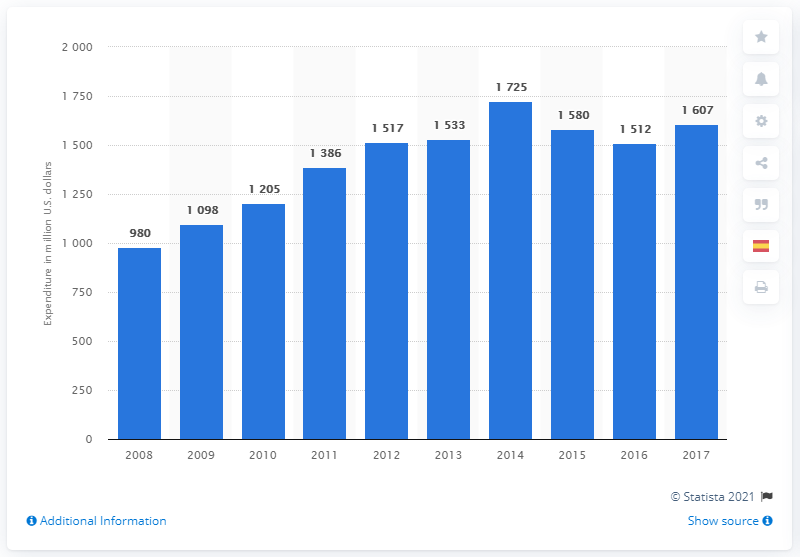Point out several critical features in this image. In 2017, Monsanto invested a significant amount of money in research and development. 